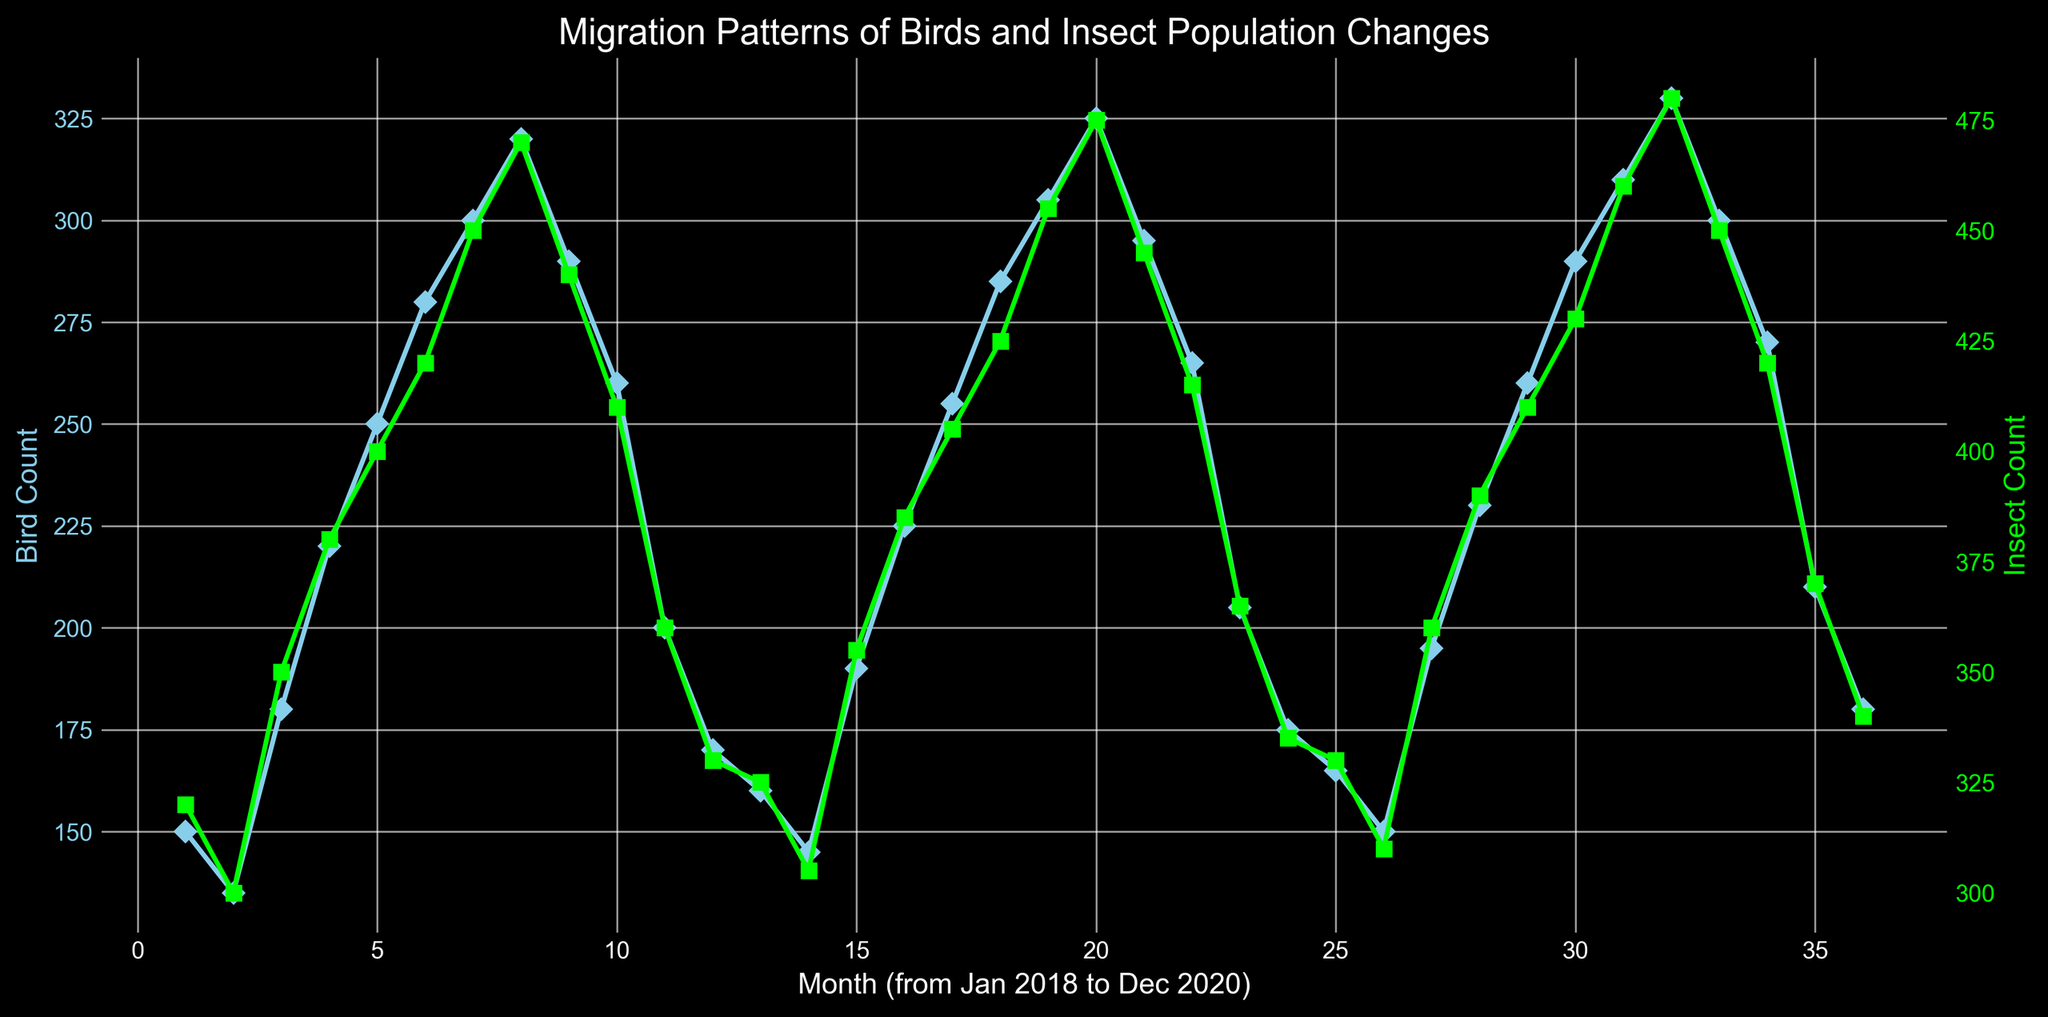Which month and year had the highest bird count and what was the corresponding insect count? Looking at the graph, the highest bird count is observed in the month corresponding to the peak of the bird count line (skyblue). Locate the highest point, which falls in the period "August 2020" and check the corresponding insect count (lime line) for that point.
Answer: August 2020 had the highest bird count of 330, corresponding to an insect count of 480 Is there a month where bird count and insect count both have a local maximum at the same time? To determine this, find local maxima in both bird count and insect count curves. The visual inspection of peaks in both curves suggests that in August for each year, both counts peak together. Verify this visually where the peaks align for both skyblue and lime lines.
Answer: Yes, in August every year What was the insect count trend before reaching its maximum value? Visually trace the lime line's slope leading up to its maximum value in August 2020. The trend shows an increase every month until it peaks in August 2020.
Answer: The insect count showed a steady increase each month until August 2020 Which dataset (birds or insects) shows more variability over the months? Compare the amplitude of fluctuations in both datasets visually. The insect count (lime line) shows a more consistent pattern with smaller changes, while the bird count (skyblue line) exhibits more pronounced ups and downs. Therefore, bird count displays more variability.
Answer: Bird count shows more variability Between the months of December 2018 and January 2019, how did the bird count change? Identify December 2018 and January 2019 points on the skyblue line. Observing these points shows that bird count increases from 170 in December 2018 to 160 in January 2019. Calculate the change as 160 - 170.
Answer: The bird count decreased by 10 In which month did birds and insects simultaneously reach their lowest counts? Identify the local minima on the bird count (skyblue) and insect count (lime) lines. Both counts are lowest in December 2020 on the graph.
Answer: December 2020 From January 2018 to December 2020, which year had the highest average bird count? Calculate the average bird count for each year by summing the monthly bird counts and dividing by 12. From the visual, it can clearly observe the central tendency of the skyblue plot values. 2019 has the highest trend line. Verify the higher visual density of markers around higher counts in 2019.
Answer: 2019 Over the three years, in which month does the insect count consistently surpass 400? Inspect the lime line and count the months where the insect counts are above the 400 mark. visually check if each August crosses that threshold. The data confirms August each year surpassing 400.
Answer: August 